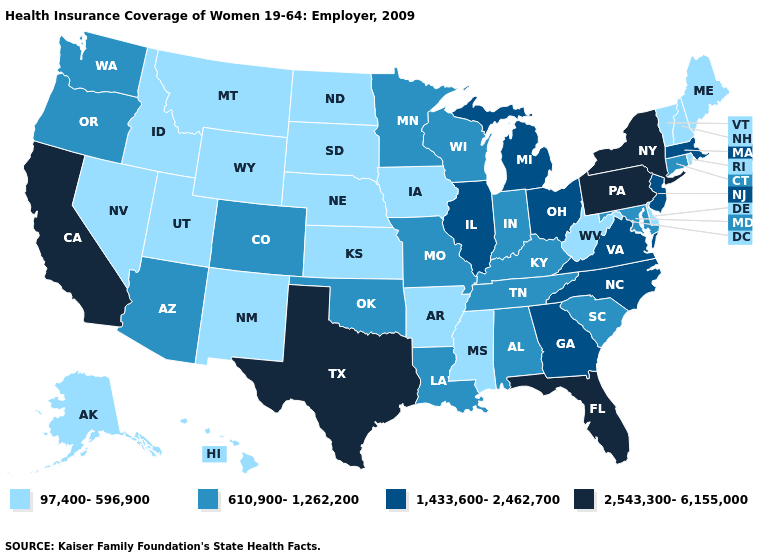What is the lowest value in the South?
Write a very short answer. 97,400-596,900. Does West Virginia have a higher value than Minnesota?
Write a very short answer. No. Name the states that have a value in the range 1,433,600-2,462,700?
Give a very brief answer. Georgia, Illinois, Massachusetts, Michigan, New Jersey, North Carolina, Ohio, Virginia. Does Wisconsin have the same value as South Dakota?
Give a very brief answer. No. What is the lowest value in states that border South Dakota?
Quick response, please. 97,400-596,900. How many symbols are there in the legend?
Quick response, please. 4. Does Texas have the highest value in the USA?
Be succinct. Yes. What is the value of Colorado?
Short answer required. 610,900-1,262,200. Does Arizona have a higher value than Minnesota?
Concise answer only. No. How many symbols are there in the legend?
Answer briefly. 4. Name the states that have a value in the range 610,900-1,262,200?
Answer briefly. Alabama, Arizona, Colorado, Connecticut, Indiana, Kentucky, Louisiana, Maryland, Minnesota, Missouri, Oklahoma, Oregon, South Carolina, Tennessee, Washington, Wisconsin. Name the states that have a value in the range 2,543,300-6,155,000?
Answer briefly. California, Florida, New York, Pennsylvania, Texas. Which states have the highest value in the USA?
Be succinct. California, Florida, New York, Pennsylvania, Texas. What is the value of Minnesota?
Keep it brief. 610,900-1,262,200. What is the value of New Mexico?
Quick response, please. 97,400-596,900. 